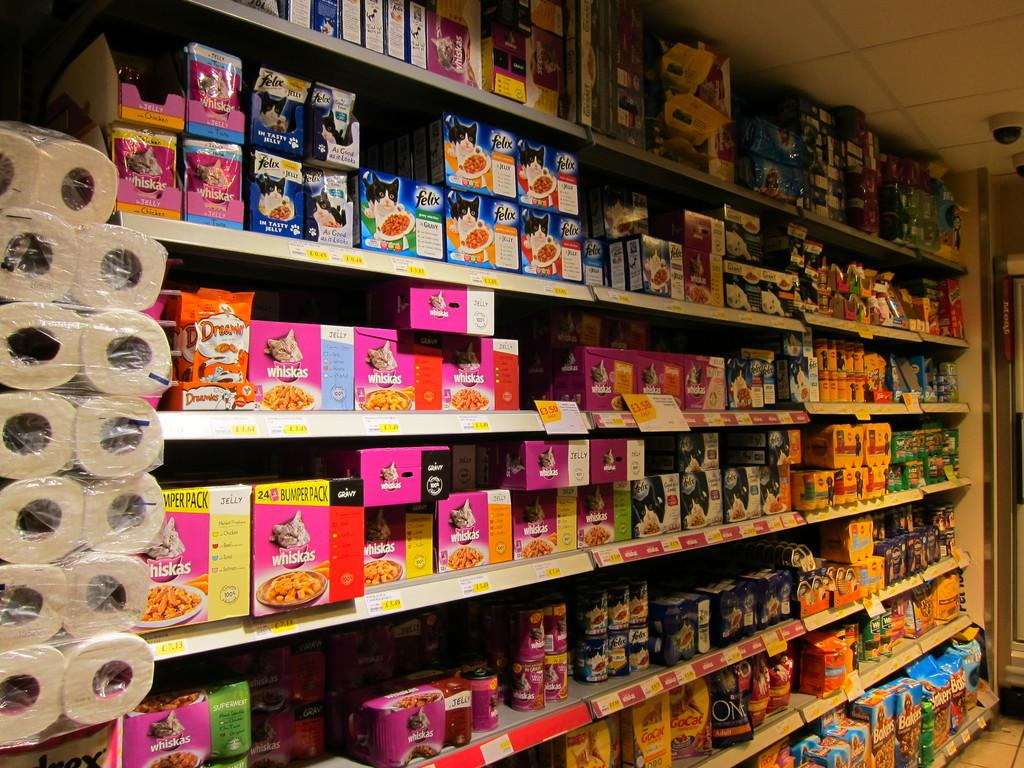Provide a one-sentence caption for the provided image. A store isle has paper towels and Whiskies cat food. 